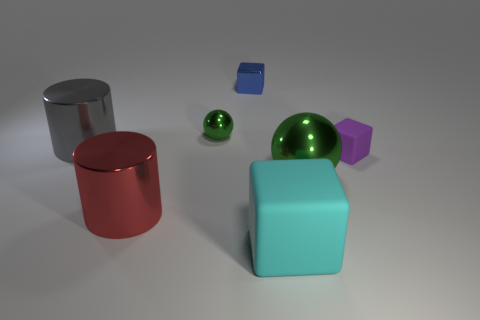Subtract all yellow spheres. Subtract all blue cylinders. How many spheres are left? 2 Add 2 small purple objects. How many objects exist? 9 Subtract all cylinders. How many objects are left? 5 Subtract all green spheres. Subtract all spheres. How many objects are left? 3 Add 3 small blue metallic cubes. How many small blue metallic cubes are left? 4 Add 3 big green metallic objects. How many big green metallic objects exist? 4 Subtract 0 cyan balls. How many objects are left? 7 